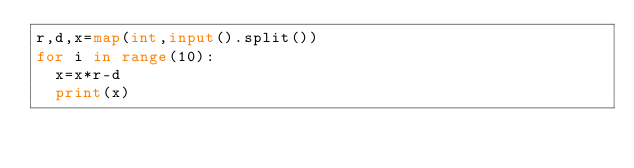<code> <loc_0><loc_0><loc_500><loc_500><_Python_>r,d,x=map(int,input().split())
for i in range(10):
  x=x*r-d
  print(x)</code> 